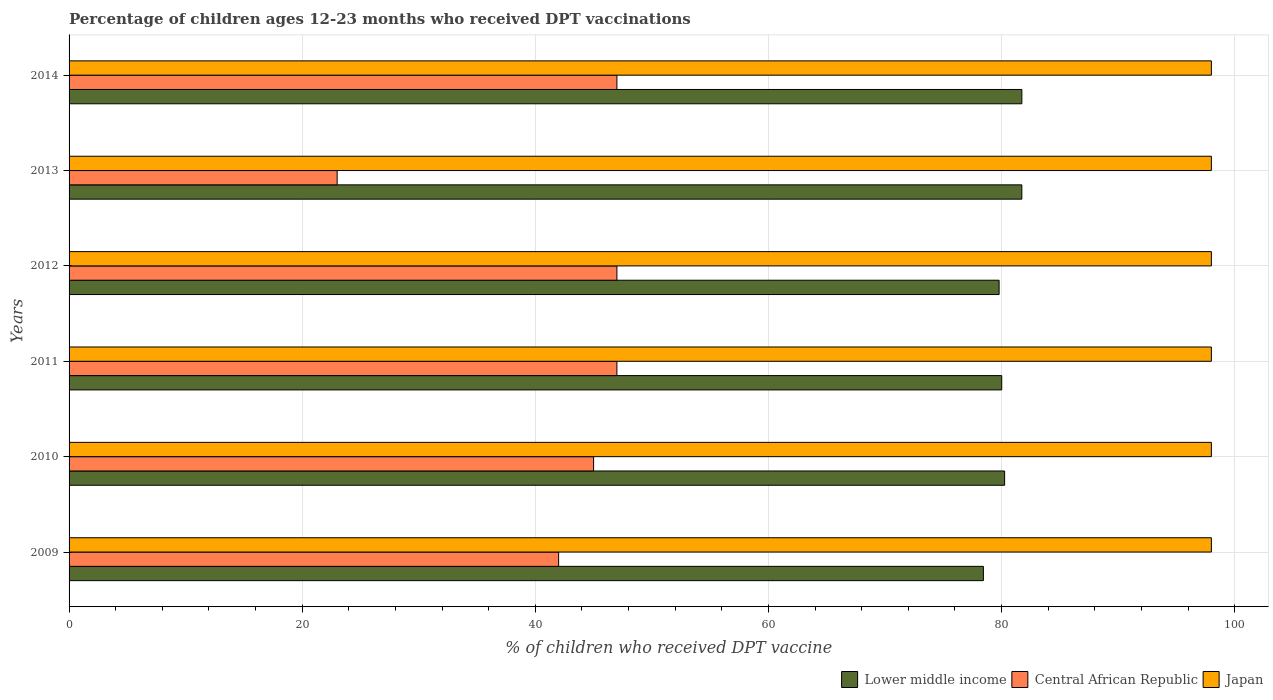How many different coloured bars are there?
Offer a very short reply. 3. Are the number of bars per tick equal to the number of legend labels?
Make the answer very short. Yes. Are the number of bars on each tick of the Y-axis equal?
Offer a terse response. Yes. How many bars are there on the 6th tick from the bottom?
Your answer should be compact. 3. What is the label of the 2nd group of bars from the top?
Offer a very short reply. 2013. In how many cases, is the number of bars for a given year not equal to the number of legend labels?
Your answer should be very brief. 0. What is the percentage of children who received DPT vaccination in Central African Republic in 2014?
Provide a short and direct response. 47. Across all years, what is the maximum percentage of children who received DPT vaccination in Japan?
Provide a short and direct response. 98. Across all years, what is the minimum percentage of children who received DPT vaccination in Central African Republic?
Keep it short and to the point. 23. In which year was the percentage of children who received DPT vaccination in Japan maximum?
Provide a short and direct response. 2009. What is the total percentage of children who received DPT vaccination in Lower middle income in the graph?
Give a very brief answer. 481.99. What is the difference between the percentage of children who received DPT vaccination in Lower middle income in 2012 and that in 2014?
Offer a terse response. -1.95. What is the difference between the percentage of children who received DPT vaccination in Japan in 2010 and the percentage of children who received DPT vaccination in Central African Republic in 2014?
Offer a terse response. 51. What is the average percentage of children who received DPT vaccination in Central African Republic per year?
Ensure brevity in your answer.  41.83. In the year 2014, what is the difference between the percentage of children who received DPT vaccination in Lower middle income and percentage of children who received DPT vaccination in Japan?
Provide a succinct answer. -16.26. In how many years, is the percentage of children who received DPT vaccination in Central African Republic greater than 48 %?
Give a very brief answer. 0. What is the difference between the highest and the lowest percentage of children who received DPT vaccination in Japan?
Give a very brief answer. 0. In how many years, is the percentage of children who received DPT vaccination in Lower middle income greater than the average percentage of children who received DPT vaccination in Lower middle income taken over all years?
Your answer should be compact. 2. What does the 2nd bar from the top in 2014 represents?
Make the answer very short. Central African Republic. Are all the bars in the graph horizontal?
Provide a succinct answer. Yes. How many years are there in the graph?
Make the answer very short. 6. What is the difference between two consecutive major ticks on the X-axis?
Make the answer very short. 20. Are the values on the major ticks of X-axis written in scientific E-notation?
Provide a succinct answer. No. Where does the legend appear in the graph?
Provide a succinct answer. Bottom right. What is the title of the graph?
Provide a succinct answer. Percentage of children ages 12-23 months who received DPT vaccinations. Does "Egypt, Arab Rep." appear as one of the legend labels in the graph?
Your answer should be very brief. No. What is the label or title of the X-axis?
Give a very brief answer. % of children who received DPT vaccine. What is the label or title of the Y-axis?
Provide a short and direct response. Years. What is the % of children who received DPT vaccine of Lower middle income in 2009?
Provide a succinct answer. 78.44. What is the % of children who received DPT vaccine in Central African Republic in 2009?
Make the answer very short. 42. What is the % of children who received DPT vaccine of Japan in 2009?
Provide a short and direct response. 98. What is the % of children who received DPT vaccine of Lower middle income in 2010?
Give a very brief answer. 80.26. What is the % of children who received DPT vaccine in Central African Republic in 2010?
Your response must be concise. 45. What is the % of children who received DPT vaccine in Japan in 2010?
Offer a terse response. 98. What is the % of children who received DPT vaccine of Lower middle income in 2011?
Ensure brevity in your answer.  80.01. What is the % of children who received DPT vaccine of Japan in 2011?
Offer a very short reply. 98. What is the % of children who received DPT vaccine in Lower middle income in 2012?
Keep it short and to the point. 79.79. What is the % of children who received DPT vaccine of Lower middle income in 2013?
Your answer should be very brief. 81.74. What is the % of children who received DPT vaccine of Lower middle income in 2014?
Ensure brevity in your answer.  81.74. What is the % of children who received DPT vaccine of Central African Republic in 2014?
Offer a very short reply. 47. What is the % of children who received DPT vaccine of Japan in 2014?
Keep it short and to the point. 98. Across all years, what is the maximum % of children who received DPT vaccine in Lower middle income?
Your answer should be very brief. 81.74. Across all years, what is the minimum % of children who received DPT vaccine in Lower middle income?
Offer a very short reply. 78.44. Across all years, what is the minimum % of children who received DPT vaccine in Central African Republic?
Offer a very short reply. 23. What is the total % of children who received DPT vaccine of Lower middle income in the graph?
Offer a very short reply. 481.99. What is the total % of children who received DPT vaccine in Central African Republic in the graph?
Keep it short and to the point. 251. What is the total % of children who received DPT vaccine in Japan in the graph?
Give a very brief answer. 588. What is the difference between the % of children who received DPT vaccine in Lower middle income in 2009 and that in 2010?
Provide a short and direct response. -1.82. What is the difference between the % of children who received DPT vaccine of Japan in 2009 and that in 2010?
Provide a succinct answer. 0. What is the difference between the % of children who received DPT vaccine of Lower middle income in 2009 and that in 2011?
Give a very brief answer. -1.57. What is the difference between the % of children who received DPT vaccine in Lower middle income in 2009 and that in 2012?
Make the answer very short. -1.35. What is the difference between the % of children who received DPT vaccine in Central African Republic in 2009 and that in 2012?
Your response must be concise. -5. What is the difference between the % of children who received DPT vaccine of Japan in 2009 and that in 2012?
Keep it short and to the point. 0. What is the difference between the % of children who received DPT vaccine in Lower middle income in 2009 and that in 2013?
Offer a very short reply. -3.3. What is the difference between the % of children who received DPT vaccine of Central African Republic in 2009 and that in 2013?
Offer a terse response. 19. What is the difference between the % of children who received DPT vaccine of Japan in 2009 and that in 2013?
Ensure brevity in your answer.  0. What is the difference between the % of children who received DPT vaccine of Lower middle income in 2009 and that in 2014?
Make the answer very short. -3.3. What is the difference between the % of children who received DPT vaccine of Central African Republic in 2009 and that in 2014?
Offer a terse response. -5. What is the difference between the % of children who received DPT vaccine of Japan in 2009 and that in 2014?
Offer a terse response. 0. What is the difference between the % of children who received DPT vaccine in Lower middle income in 2010 and that in 2011?
Provide a succinct answer. 0.25. What is the difference between the % of children who received DPT vaccine in Lower middle income in 2010 and that in 2012?
Give a very brief answer. 0.47. What is the difference between the % of children who received DPT vaccine of Lower middle income in 2010 and that in 2013?
Your answer should be compact. -1.48. What is the difference between the % of children who received DPT vaccine in Central African Republic in 2010 and that in 2013?
Give a very brief answer. 22. What is the difference between the % of children who received DPT vaccine in Lower middle income in 2010 and that in 2014?
Your answer should be compact. -1.48. What is the difference between the % of children who received DPT vaccine of Central African Republic in 2010 and that in 2014?
Provide a succinct answer. -2. What is the difference between the % of children who received DPT vaccine in Lower middle income in 2011 and that in 2012?
Your answer should be very brief. 0.22. What is the difference between the % of children who received DPT vaccine in Central African Republic in 2011 and that in 2012?
Offer a terse response. 0. What is the difference between the % of children who received DPT vaccine in Lower middle income in 2011 and that in 2013?
Your response must be concise. -1.72. What is the difference between the % of children who received DPT vaccine in Japan in 2011 and that in 2013?
Ensure brevity in your answer.  0. What is the difference between the % of children who received DPT vaccine of Lower middle income in 2011 and that in 2014?
Provide a succinct answer. -1.73. What is the difference between the % of children who received DPT vaccine of Central African Republic in 2011 and that in 2014?
Ensure brevity in your answer.  0. What is the difference between the % of children who received DPT vaccine of Lower middle income in 2012 and that in 2013?
Ensure brevity in your answer.  -1.95. What is the difference between the % of children who received DPT vaccine of Japan in 2012 and that in 2013?
Keep it short and to the point. 0. What is the difference between the % of children who received DPT vaccine in Lower middle income in 2012 and that in 2014?
Offer a terse response. -1.95. What is the difference between the % of children who received DPT vaccine in Central African Republic in 2012 and that in 2014?
Offer a terse response. 0. What is the difference between the % of children who received DPT vaccine of Japan in 2012 and that in 2014?
Keep it short and to the point. 0. What is the difference between the % of children who received DPT vaccine of Lower middle income in 2013 and that in 2014?
Make the answer very short. -0. What is the difference between the % of children who received DPT vaccine of Central African Republic in 2013 and that in 2014?
Make the answer very short. -24. What is the difference between the % of children who received DPT vaccine in Japan in 2013 and that in 2014?
Your answer should be compact. 0. What is the difference between the % of children who received DPT vaccine of Lower middle income in 2009 and the % of children who received DPT vaccine of Central African Republic in 2010?
Make the answer very short. 33.44. What is the difference between the % of children who received DPT vaccine of Lower middle income in 2009 and the % of children who received DPT vaccine of Japan in 2010?
Your response must be concise. -19.56. What is the difference between the % of children who received DPT vaccine in Central African Republic in 2009 and the % of children who received DPT vaccine in Japan in 2010?
Make the answer very short. -56. What is the difference between the % of children who received DPT vaccine of Lower middle income in 2009 and the % of children who received DPT vaccine of Central African Republic in 2011?
Provide a short and direct response. 31.44. What is the difference between the % of children who received DPT vaccine in Lower middle income in 2009 and the % of children who received DPT vaccine in Japan in 2011?
Keep it short and to the point. -19.56. What is the difference between the % of children who received DPT vaccine of Central African Republic in 2009 and the % of children who received DPT vaccine of Japan in 2011?
Provide a succinct answer. -56. What is the difference between the % of children who received DPT vaccine of Lower middle income in 2009 and the % of children who received DPT vaccine of Central African Republic in 2012?
Ensure brevity in your answer.  31.44. What is the difference between the % of children who received DPT vaccine in Lower middle income in 2009 and the % of children who received DPT vaccine in Japan in 2012?
Ensure brevity in your answer.  -19.56. What is the difference between the % of children who received DPT vaccine of Central African Republic in 2009 and the % of children who received DPT vaccine of Japan in 2012?
Provide a short and direct response. -56. What is the difference between the % of children who received DPT vaccine in Lower middle income in 2009 and the % of children who received DPT vaccine in Central African Republic in 2013?
Offer a terse response. 55.44. What is the difference between the % of children who received DPT vaccine in Lower middle income in 2009 and the % of children who received DPT vaccine in Japan in 2013?
Ensure brevity in your answer.  -19.56. What is the difference between the % of children who received DPT vaccine in Central African Republic in 2009 and the % of children who received DPT vaccine in Japan in 2013?
Your answer should be compact. -56. What is the difference between the % of children who received DPT vaccine in Lower middle income in 2009 and the % of children who received DPT vaccine in Central African Republic in 2014?
Keep it short and to the point. 31.44. What is the difference between the % of children who received DPT vaccine in Lower middle income in 2009 and the % of children who received DPT vaccine in Japan in 2014?
Provide a short and direct response. -19.56. What is the difference between the % of children who received DPT vaccine of Central African Republic in 2009 and the % of children who received DPT vaccine of Japan in 2014?
Provide a succinct answer. -56. What is the difference between the % of children who received DPT vaccine of Lower middle income in 2010 and the % of children who received DPT vaccine of Central African Republic in 2011?
Provide a succinct answer. 33.26. What is the difference between the % of children who received DPT vaccine in Lower middle income in 2010 and the % of children who received DPT vaccine in Japan in 2011?
Your response must be concise. -17.74. What is the difference between the % of children who received DPT vaccine of Central African Republic in 2010 and the % of children who received DPT vaccine of Japan in 2011?
Give a very brief answer. -53. What is the difference between the % of children who received DPT vaccine in Lower middle income in 2010 and the % of children who received DPT vaccine in Central African Republic in 2012?
Give a very brief answer. 33.26. What is the difference between the % of children who received DPT vaccine in Lower middle income in 2010 and the % of children who received DPT vaccine in Japan in 2012?
Ensure brevity in your answer.  -17.74. What is the difference between the % of children who received DPT vaccine in Central African Republic in 2010 and the % of children who received DPT vaccine in Japan in 2012?
Offer a terse response. -53. What is the difference between the % of children who received DPT vaccine in Lower middle income in 2010 and the % of children who received DPT vaccine in Central African Republic in 2013?
Your answer should be very brief. 57.26. What is the difference between the % of children who received DPT vaccine in Lower middle income in 2010 and the % of children who received DPT vaccine in Japan in 2013?
Provide a succinct answer. -17.74. What is the difference between the % of children who received DPT vaccine of Central African Republic in 2010 and the % of children who received DPT vaccine of Japan in 2013?
Provide a succinct answer. -53. What is the difference between the % of children who received DPT vaccine in Lower middle income in 2010 and the % of children who received DPT vaccine in Central African Republic in 2014?
Provide a succinct answer. 33.26. What is the difference between the % of children who received DPT vaccine of Lower middle income in 2010 and the % of children who received DPT vaccine of Japan in 2014?
Provide a short and direct response. -17.74. What is the difference between the % of children who received DPT vaccine in Central African Republic in 2010 and the % of children who received DPT vaccine in Japan in 2014?
Make the answer very short. -53. What is the difference between the % of children who received DPT vaccine in Lower middle income in 2011 and the % of children who received DPT vaccine in Central African Republic in 2012?
Provide a succinct answer. 33.01. What is the difference between the % of children who received DPT vaccine in Lower middle income in 2011 and the % of children who received DPT vaccine in Japan in 2012?
Ensure brevity in your answer.  -17.99. What is the difference between the % of children who received DPT vaccine in Central African Republic in 2011 and the % of children who received DPT vaccine in Japan in 2012?
Provide a short and direct response. -51. What is the difference between the % of children who received DPT vaccine in Lower middle income in 2011 and the % of children who received DPT vaccine in Central African Republic in 2013?
Give a very brief answer. 57.01. What is the difference between the % of children who received DPT vaccine in Lower middle income in 2011 and the % of children who received DPT vaccine in Japan in 2013?
Your answer should be compact. -17.99. What is the difference between the % of children who received DPT vaccine in Central African Republic in 2011 and the % of children who received DPT vaccine in Japan in 2013?
Keep it short and to the point. -51. What is the difference between the % of children who received DPT vaccine of Lower middle income in 2011 and the % of children who received DPT vaccine of Central African Republic in 2014?
Offer a terse response. 33.01. What is the difference between the % of children who received DPT vaccine of Lower middle income in 2011 and the % of children who received DPT vaccine of Japan in 2014?
Give a very brief answer. -17.99. What is the difference between the % of children who received DPT vaccine of Central African Republic in 2011 and the % of children who received DPT vaccine of Japan in 2014?
Give a very brief answer. -51. What is the difference between the % of children who received DPT vaccine of Lower middle income in 2012 and the % of children who received DPT vaccine of Central African Republic in 2013?
Make the answer very short. 56.79. What is the difference between the % of children who received DPT vaccine of Lower middle income in 2012 and the % of children who received DPT vaccine of Japan in 2013?
Give a very brief answer. -18.21. What is the difference between the % of children who received DPT vaccine of Central African Republic in 2012 and the % of children who received DPT vaccine of Japan in 2013?
Offer a very short reply. -51. What is the difference between the % of children who received DPT vaccine in Lower middle income in 2012 and the % of children who received DPT vaccine in Central African Republic in 2014?
Keep it short and to the point. 32.79. What is the difference between the % of children who received DPT vaccine of Lower middle income in 2012 and the % of children who received DPT vaccine of Japan in 2014?
Provide a succinct answer. -18.21. What is the difference between the % of children who received DPT vaccine of Central African Republic in 2012 and the % of children who received DPT vaccine of Japan in 2014?
Make the answer very short. -51. What is the difference between the % of children who received DPT vaccine of Lower middle income in 2013 and the % of children who received DPT vaccine of Central African Republic in 2014?
Offer a very short reply. 34.74. What is the difference between the % of children who received DPT vaccine in Lower middle income in 2013 and the % of children who received DPT vaccine in Japan in 2014?
Your answer should be compact. -16.26. What is the difference between the % of children who received DPT vaccine of Central African Republic in 2013 and the % of children who received DPT vaccine of Japan in 2014?
Your answer should be compact. -75. What is the average % of children who received DPT vaccine in Lower middle income per year?
Offer a very short reply. 80.33. What is the average % of children who received DPT vaccine in Central African Republic per year?
Provide a succinct answer. 41.83. What is the average % of children who received DPT vaccine in Japan per year?
Your answer should be compact. 98. In the year 2009, what is the difference between the % of children who received DPT vaccine of Lower middle income and % of children who received DPT vaccine of Central African Republic?
Offer a terse response. 36.44. In the year 2009, what is the difference between the % of children who received DPT vaccine of Lower middle income and % of children who received DPT vaccine of Japan?
Provide a succinct answer. -19.56. In the year 2009, what is the difference between the % of children who received DPT vaccine of Central African Republic and % of children who received DPT vaccine of Japan?
Your answer should be very brief. -56. In the year 2010, what is the difference between the % of children who received DPT vaccine in Lower middle income and % of children who received DPT vaccine in Central African Republic?
Keep it short and to the point. 35.26. In the year 2010, what is the difference between the % of children who received DPT vaccine in Lower middle income and % of children who received DPT vaccine in Japan?
Ensure brevity in your answer.  -17.74. In the year 2010, what is the difference between the % of children who received DPT vaccine in Central African Republic and % of children who received DPT vaccine in Japan?
Provide a succinct answer. -53. In the year 2011, what is the difference between the % of children who received DPT vaccine of Lower middle income and % of children who received DPT vaccine of Central African Republic?
Offer a terse response. 33.01. In the year 2011, what is the difference between the % of children who received DPT vaccine in Lower middle income and % of children who received DPT vaccine in Japan?
Ensure brevity in your answer.  -17.99. In the year 2011, what is the difference between the % of children who received DPT vaccine in Central African Republic and % of children who received DPT vaccine in Japan?
Keep it short and to the point. -51. In the year 2012, what is the difference between the % of children who received DPT vaccine in Lower middle income and % of children who received DPT vaccine in Central African Republic?
Ensure brevity in your answer.  32.79. In the year 2012, what is the difference between the % of children who received DPT vaccine in Lower middle income and % of children who received DPT vaccine in Japan?
Your answer should be very brief. -18.21. In the year 2012, what is the difference between the % of children who received DPT vaccine in Central African Republic and % of children who received DPT vaccine in Japan?
Your answer should be compact. -51. In the year 2013, what is the difference between the % of children who received DPT vaccine of Lower middle income and % of children who received DPT vaccine of Central African Republic?
Provide a short and direct response. 58.74. In the year 2013, what is the difference between the % of children who received DPT vaccine of Lower middle income and % of children who received DPT vaccine of Japan?
Offer a terse response. -16.26. In the year 2013, what is the difference between the % of children who received DPT vaccine of Central African Republic and % of children who received DPT vaccine of Japan?
Provide a succinct answer. -75. In the year 2014, what is the difference between the % of children who received DPT vaccine of Lower middle income and % of children who received DPT vaccine of Central African Republic?
Offer a very short reply. 34.74. In the year 2014, what is the difference between the % of children who received DPT vaccine of Lower middle income and % of children who received DPT vaccine of Japan?
Offer a very short reply. -16.26. In the year 2014, what is the difference between the % of children who received DPT vaccine of Central African Republic and % of children who received DPT vaccine of Japan?
Provide a short and direct response. -51. What is the ratio of the % of children who received DPT vaccine of Lower middle income in 2009 to that in 2010?
Your response must be concise. 0.98. What is the ratio of the % of children who received DPT vaccine in Central African Republic in 2009 to that in 2010?
Make the answer very short. 0.93. What is the ratio of the % of children who received DPT vaccine of Lower middle income in 2009 to that in 2011?
Ensure brevity in your answer.  0.98. What is the ratio of the % of children who received DPT vaccine of Central African Republic in 2009 to that in 2011?
Your answer should be compact. 0.89. What is the ratio of the % of children who received DPT vaccine of Lower middle income in 2009 to that in 2012?
Give a very brief answer. 0.98. What is the ratio of the % of children who received DPT vaccine in Central African Republic in 2009 to that in 2012?
Give a very brief answer. 0.89. What is the ratio of the % of children who received DPT vaccine in Japan in 2009 to that in 2012?
Keep it short and to the point. 1. What is the ratio of the % of children who received DPT vaccine in Lower middle income in 2009 to that in 2013?
Your response must be concise. 0.96. What is the ratio of the % of children who received DPT vaccine in Central African Republic in 2009 to that in 2013?
Your response must be concise. 1.83. What is the ratio of the % of children who received DPT vaccine of Lower middle income in 2009 to that in 2014?
Your answer should be compact. 0.96. What is the ratio of the % of children who received DPT vaccine in Central African Republic in 2009 to that in 2014?
Provide a succinct answer. 0.89. What is the ratio of the % of children who received DPT vaccine in Japan in 2009 to that in 2014?
Your answer should be very brief. 1. What is the ratio of the % of children who received DPT vaccine of Central African Republic in 2010 to that in 2011?
Make the answer very short. 0.96. What is the ratio of the % of children who received DPT vaccine of Lower middle income in 2010 to that in 2012?
Your answer should be compact. 1.01. What is the ratio of the % of children who received DPT vaccine of Central African Republic in 2010 to that in 2012?
Offer a terse response. 0.96. What is the ratio of the % of children who received DPT vaccine of Lower middle income in 2010 to that in 2013?
Keep it short and to the point. 0.98. What is the ratio of the % of children who received DPT vaccine in Central African Republic in 2010 to that in 2013?
Offer a terse response. 1.96. What is the ratio of the % of children who received DPT vaccine of Lower middle income in 2010 to that in 2014?
Make the answer very short. 0.98. What is the ratio of the % of children who received DPT vaccine in Central African Republic in 2010 to that in 2014?
Provide a succinct answer. 0.96. What is the ratio of the % of children who received DPT vaccine of Japan in 2010 to that in 2014?
Provide a short and direct response. 1. What is the ratio of the % of children who received DPT vaccine in Central African Republic in 2011 to that in 2012?
Keep it short and to the point. 1. What is the ratio of the % of children who received DPT vaccine of Lower middle income in 2011 to that in 2013?
Give a very brief answer. 0.98. What is the ratio of the % of children who received DPT vaccine of Central African Republic in 2011 to that in 2013?
Provide a succinct answer. 2.04. What is the ratio of the % of children who received DPT vaccine of Lower middle income in 2011 to that in 2014?
Make the answer very short. 0.98. What is the ratio of the % of children who received DPT vaccine in Central African Republic in 2011 to that in 2014?
Offer a very short reply. 1. What is the ratio of the % of children who received DPT vaccine of Lower middle income in 2012 to that in 2013?
Offer a very short reply. 0.98. What is the ratio of the % of children who received DPT vaccine in Central African Republic in 2012 to that in 2013?
Ensure brevity in your answer.  2.04. What is the ratio of the % of children who received DPT vaccine in Lower middle income in 2012 to that in 2014?
Provide a succinct answer. 0.98. What is the ratio of the % of children who received DPT vaccine of Central African Republic in 2012 to that in 2014?
Your answer should be very brief. 1. What is the ratio of the % of children who received DPT vaccine of Japan in 2012 to that in 2014?
Your answer should be compact. 1. What is the ratio of the % of children who received DPT vaccine of Lower middle income in 2013 to that in 2014?
Offer a terse response. 1. What is the ratio of the % of children who received DPT vaccine in Central African Republic in 2013 to that in 2014?
Your answer should be compact. 0.49. What is the ratio of the % of children who received DPT vaccine of Japan in 2013 to that in 2014?
Offer a terse response. 1. What is the difference between the highest and the second highest % of children who received DPT vaccine in Lower middle income?
Ensure brevity in your answer.  0. What is the difference between the highest and the second highest % of children who received DPT vaccine in Central African Republic?
Provide a short and direct response. 0. What is the difference between the highest and the second highest % of children who received DPT vaccine in Japan?
Make the answer very short. 0. What is the difference between the highest and the lowest % of children who received DPT vaccine of Lower middle income?
Keep it short and to the point. 3.3. What is the difference between the highest and the lowest % of children who received DPT vaccine in Japan?
Offer a terse response. 0. 